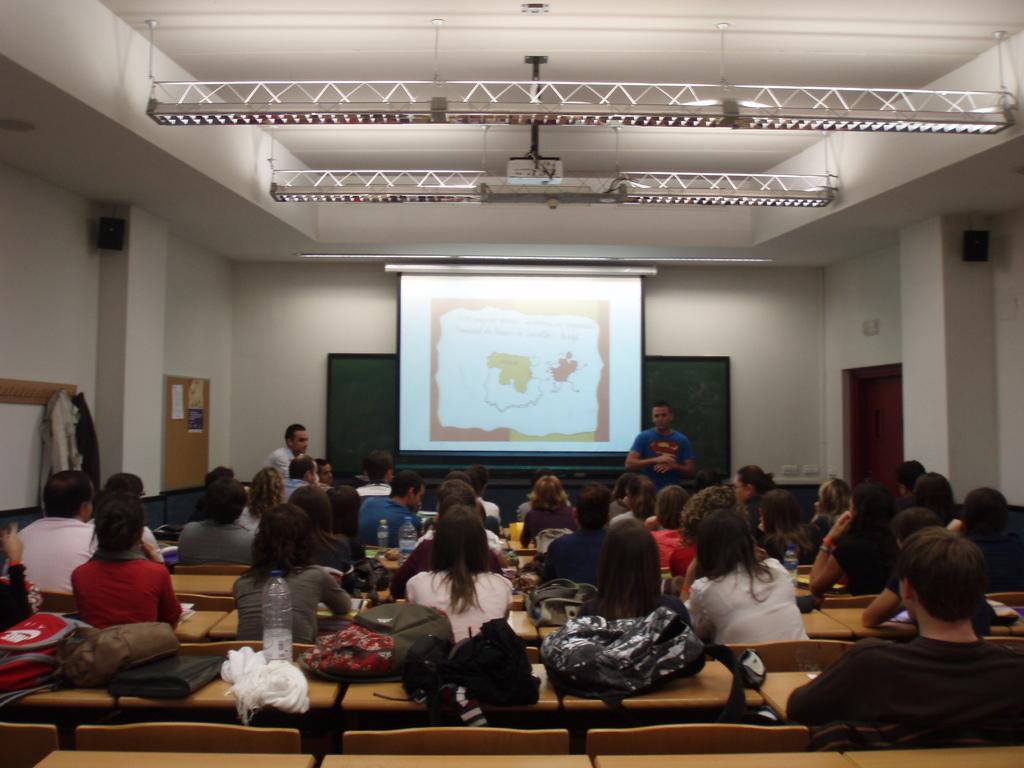How would you summarize this image in a sentence or two? In this image there is a person standing and delivering a lecture in front of students sitting on chairs, behind the person there is a projector screen, at the top of the image there is a projector hanging, behind the screen there is a board. 